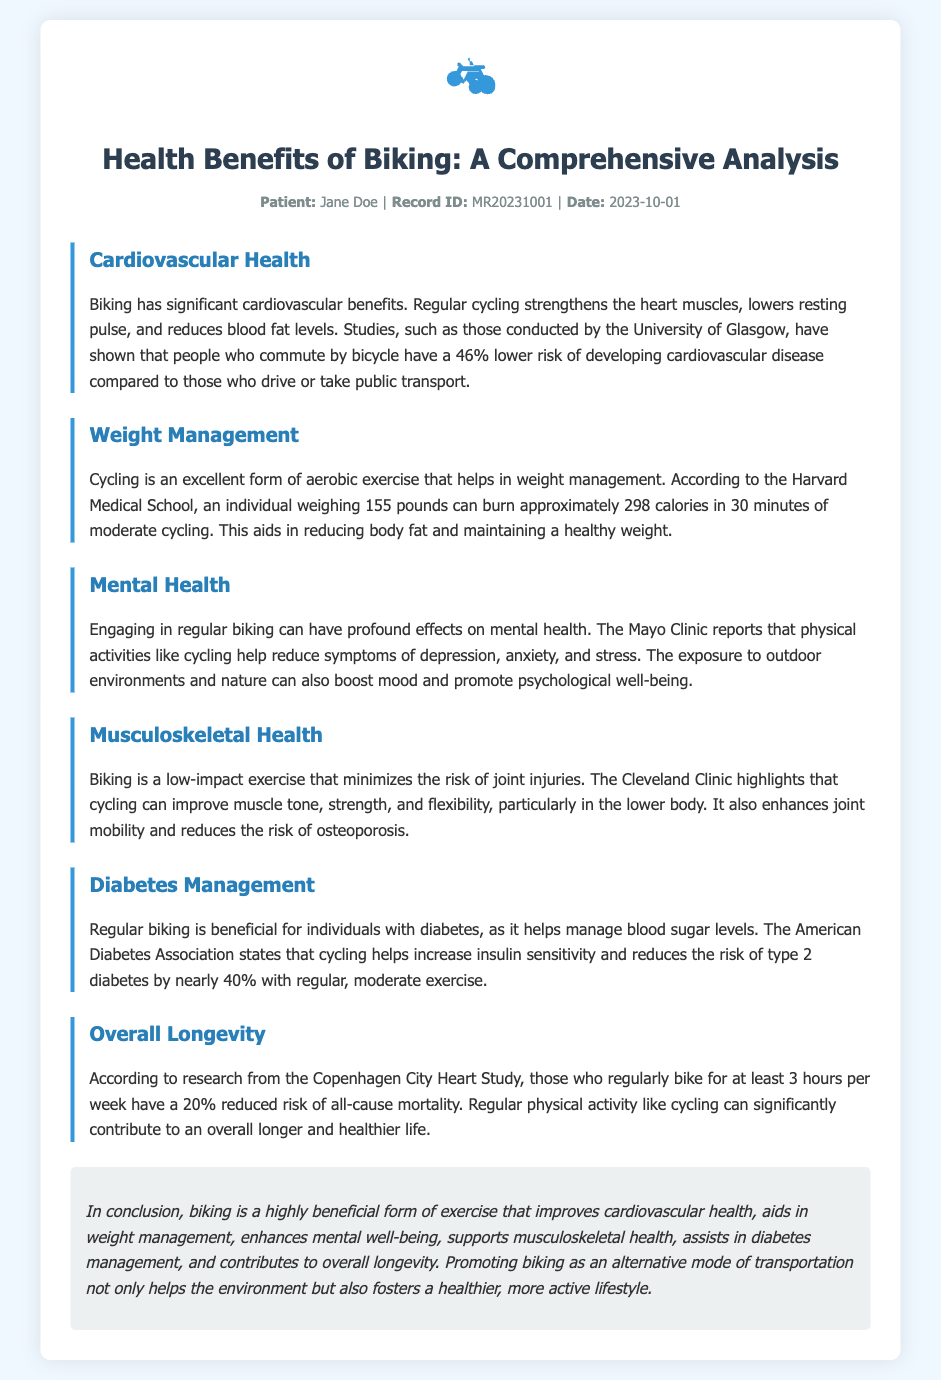what is the title of the document? The title is provided in the header of the document and indicates the main focus of the content.
Answer: Health Benefits of Biking: A Comprehensive Analysis who is the patient mentioned in the document? The patient's name is specified in the record info section.
Answer: Jane Doe what percentage lower risk of cardiovascular disease do cyclists have? The document cites a specific percentage based on studies conducted by the University of Glasgow.
Answer: 46% how many calories can a person weighing 155 pounds burn in 30 minutes of moderate cycling? The document presents a specific calorie-burning figure from Harvard Medical School.
Answer: 298 which institution reports that physical activities like cycling help reduce symptoms of depression? The document attributes this information to a well-known medical organization that focuses on health.
Answer: Mayo Clinic what type of exercise is biking classified as? The document describes biking in terms of its impact on the joints.
Answer: Low-impact exercise how much can regular biking reduce the risk of type 2 diabetes? The document mentions a specific percentage reduction associated with regular moderate exercise.
Answer: Nearly 40% what is the reduced risk of all-cause mortality for those who bike at least 3 hours per week? The document refers to research that quantifies this reduction in mortality risk.
Answer: 20% in what way does biking support musculoskeletal health according to the Cleveland Clinic? The document states an advantage related to joint health and flexibility.
Answer: Improves muscle tone, strength, and flexibility 